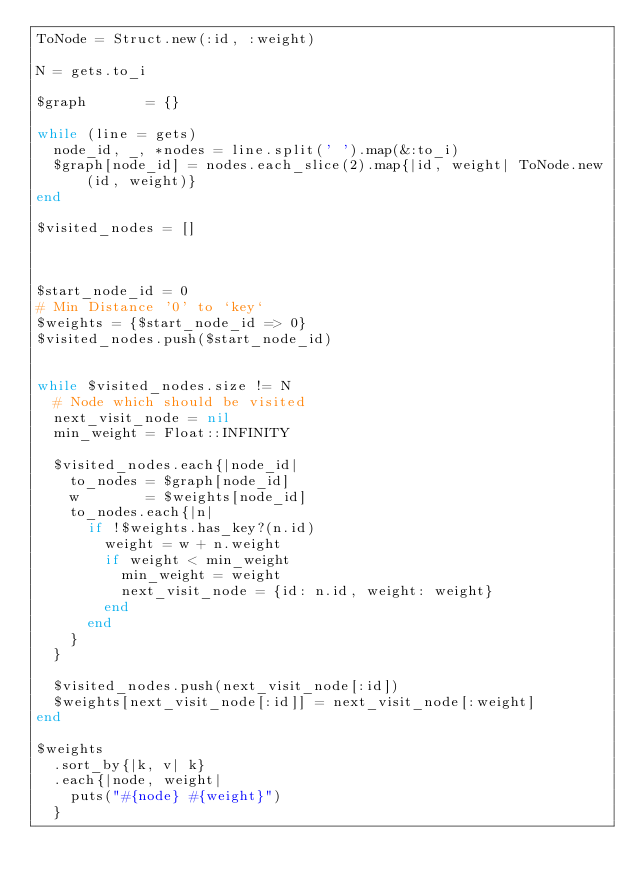<code> <loc_0><loc_0><loc_500><loc_500><_Ruby_>ToNode = Struct.new(:id, :weight)

N = gets.to_i

$graph       = {}

while (line = gets)
  node_id, _, *nodes = line.split(' ').map(&:to_i)
  $graph[node_id] = nodes.each_slice(2).map{|id, weight| ToNode.new(id, weight)}
end

$visited_nodes = []



$start_node_id = 0
# Min Distance '0' to `key`
$weights = {$start_node_id => 0}
$visited_nodes.push($start_node_id)


while $visited_nodes.size != N
  # Node which should be visited
  next_visit_node = nil
  min_weight = Float::INFINITY

  $visited_nodes.each{|node_id|
    to_nodes = $graph[node_id]
    w        = $weights[node_id]
    to_nodes.each{|n|
      if !$weights.has_key?(n.id)
        weight = w + n.weight
        if weight < min_weight
          min_weight = weight
          next_visit_node = {id: n.id, weight: weight}
        end
      end
    }
  }

  $visited_nodes.push(next_visit_node[:id])
  $weights[next_visit_node[:id]] = next_visit_node[:weight]
end

$weights
  .sort_by{|k, v| k}
  .each{|node, weight|
    puts("#{node} #{weight}")
  }

</code> 